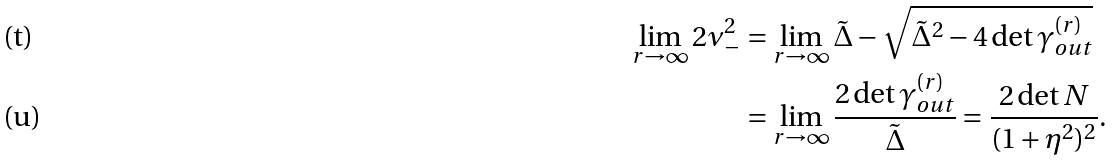<formula> <loc_0><loc_0><loc_500><loc_500>\lim _ { r \rightarrow \infty } 2 \nu _ { - } ^ { 2 } & = \lim _ { r \rightarrow \infty } \tilde { \Delta } - \sqrt { \tilde { \Delta } ^ { 2 } - 4 \det \gamma ^ { ( r ) } _ { o u t } } \\ & = \lim _ { r \rightarrow \infty } \frac { 2 \det \gamma ^ { ( r ) } _ { o u t } } { \tilde { \Delta } } = \frac { 2 \det N } { ( 1 + \eta ^ { 2 } ) ^ { 2 } } .</formula> 